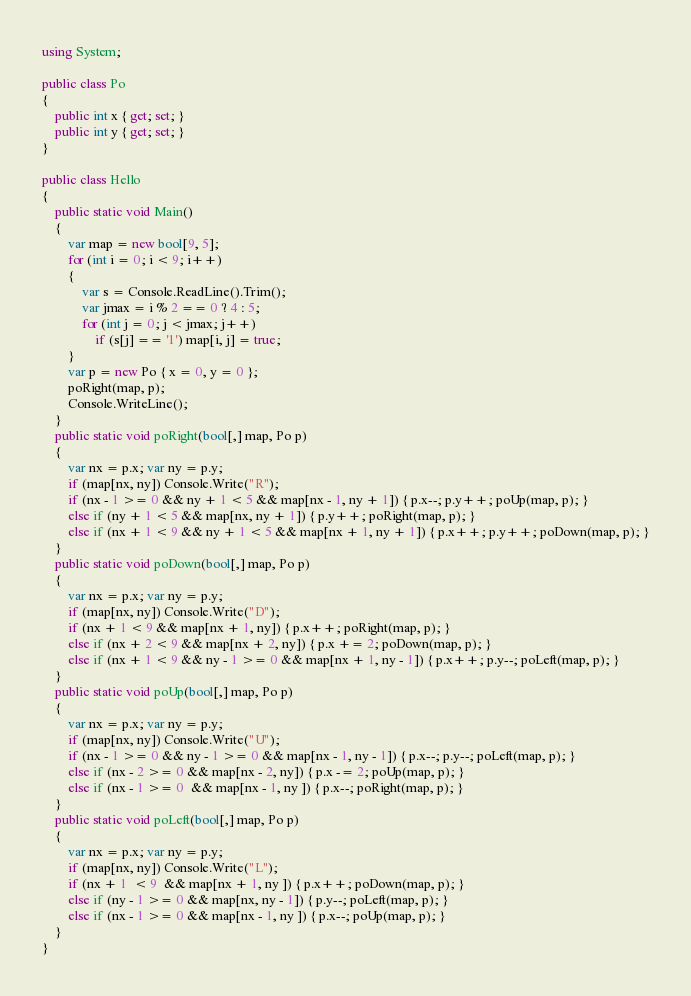<code> <loc_0><loc_0><loc_500><loc_500><_C#_>using System;

public class Po
{
    public int x { get; set; }
    public int y { get; set; }
}

public class Hello
{
    public static void Main()
    {
        var map = new bool[9, 5];
        for (int i = 0; i < 9; i++)
        {
            var s = Console.ReadLine().Trim();
            var jmax = i % 2 == 0 ? 4 : 5;
            for (int j = 0; j < jmax; j++)
                if (s[j] == '1') map[i, j] = true;
        }
        var p = new Po { x = 0, y = 0 };
        poRight(map, p);
        Console.WriteLine();
    }
    public static void poRight(bool[,] map, Po p)
    {
        var nx = p.x; var ny = p.y;
        if (map[nx, ny]) Console.Write("R");
        if (nx - 1 >= 0 && ny + 1 < 5 && map[nx - 1, ny + 1]) { p.x--; p.y++; poUp(map, p); }  
        else if (ny + 1 < 5 && map[nx, ny + 1]) { p.y++; poRight(map, p); }
        else if (nx + 1 < 9 && ny + 1 < 5 && map[nx + 1, ny + 1]) { p.x++; p.y++; poDown(map, p); }
    }
    public static void poDown(bool[,] map, Po p)
    {
        var nx = p.x; var ny = p.y;
        if (map[nx, ny]) Console.Write("D");
        if (nx + 1 < 9 && map[nx + 1, ny]) { p.x++; poRight(map, p); }
        else if (nx + 2 < 9 && map[nx + 2, ny]) { p.x += 2; poDown(map, p); }
        else if (nx + 1 < 9 && ny - 1 >= 0 && map[nx + 1, ny - 1]) { p.x++; p.y--; poLeft(map, p); } 
    }
    public static void poUp(bool[,] map, Po p)
    {
        var nx = p.x; var ny = p.y;
        if (map[nx, ny]) Console.Write("U");
        if (nx - 1 >= 0 && ny - 1 >= 0 && map[nx - 1, ny - 1]) { p.x--; p.y--; poLeft(map, p); } 
        else if (nx - 2 >= 0 && map[nx - 2, ny]) { p.x -= 2; poUp(map, p); }
        else if (nx - 1 >= 0  && map[nx - 1, ny ]) { p.x--; poRight(map, p); } 
    }
    public static void poLeft(bool[,] map, Po p)
    {
        var nx = p.x; var ny = p.y;
        if (map[nx, ny]) Console.Write("L");
        if (nx + 1  < 9  && map[nx + 1, ny ]) { p.x++; poDown(map, p); }
        else if (ny - 1 >= 0 && map[nx, ny - 1]) { p.y--; poLeft(map, p); }
        else if (nx - 1 >= 0 && map[nx - 1, ny ]) { p.x--; poUp(map, p); }
    }
}</code> 